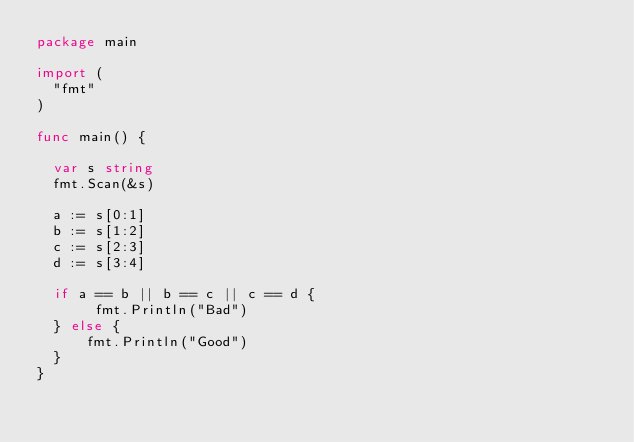Convert code to text. <code><loc_0><loc_0><loc_500><loc_500><_Go_>package main

import (
  "fmt"
)

func main() {

  var s string
  fmt.Scan(&s)
  
  a := s[0:1]
  b := s[1:2]
  c := s[2:3]
  d := s[3:4]
  
  if a == b || b == c || c == d {
       fmt.Println("Bad") 
  } else {
      fmt.Println("Good")
  }
}</code> 